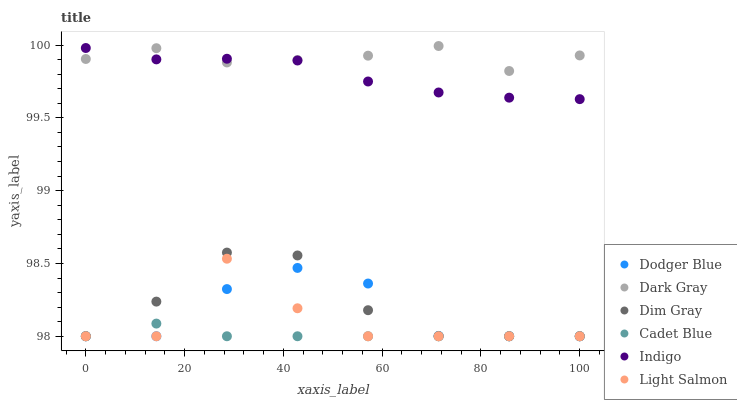Does Cadet Blue have the minimum area under the curve?
Answer yes or no. Yes. Does Dark Gray have the maximum area under the curve?
Answer yes or no. Yes. Does Dim Gray have the minimum area under the curve?
Answer yes or no. No. Does Dim Gray have the maximum area under the curve?
Answer yes or no. No. Is Cadet Blue the smoothest?
Answer yes or no. Yes. Is Light Salmon the roughest?
Answer yes or no. Yes. Is Dim Gray the smoothest?
Answer yes or no. No. Is Dim Gray the roughest?
Answer yes or no. No. Does Light Salmon have the lowest value?
Answer yes or no. Yes. Does Indigo have the lowest value?
Answer yes or no. No. Does Dark Gray have the highest value?
Answer yes or no. Yes. Does Dim Gray have the highest value?
Answer yes or no. No. Is Dodger Blue less than Indigo?
Answer yes or no. Yes. Is Dark Gray greater than Dim Gray?
Answer yes or no. Yes. Does Light Salmon intersect Dodger Blue?
Answer yes or no. Yes. Is Light Salmon less than Dodger Blue?
Answer yes or no. No. Is Light Salmon greater than Dodger Blue?
Answer yes or no. No. Does Dodger Blue intersect Indigo?
Answer yes or no. No. 